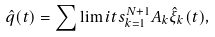<formula> <loc_0><loc_0><loc_500><loc_500>\hat { q } ( t ) = \sum \lim i t s _ { k = 1 } ^ { N + 1 } A _ { k } \hat { \xi } _ { k } ( t ) ,</formula> 